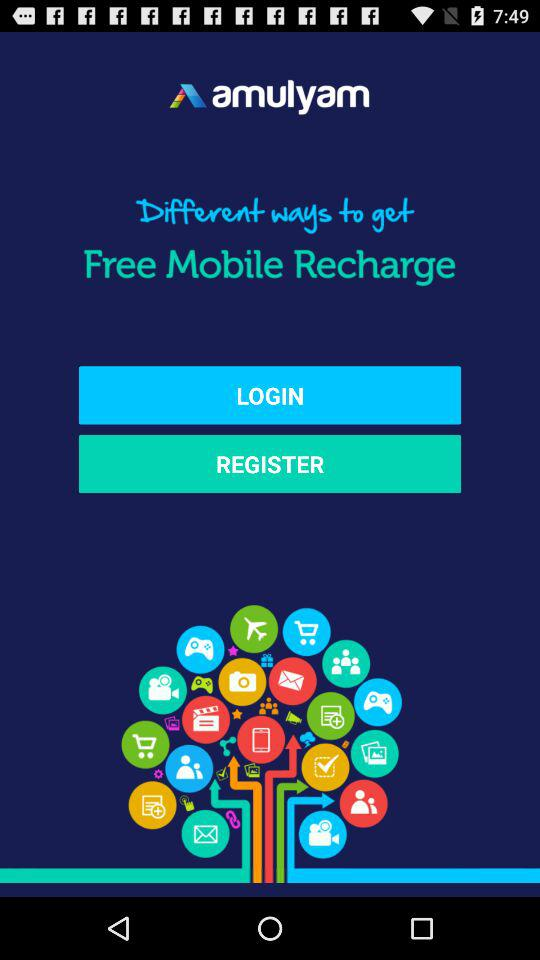What is the application name? The application name is "amulyam". 